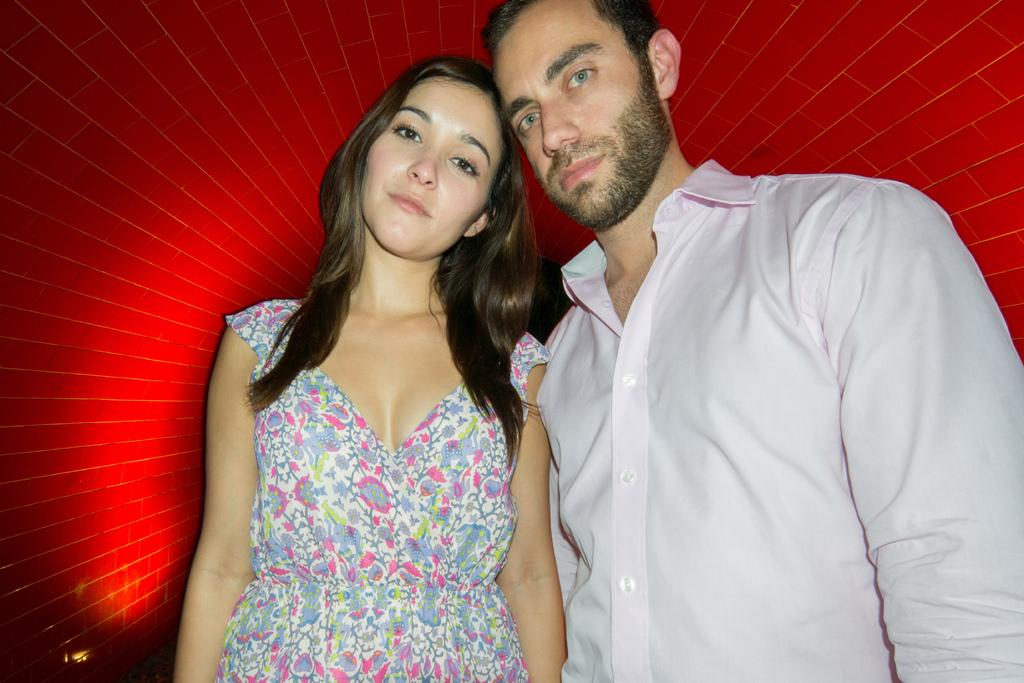Who are the people in the image? There is a man and a woman in the image. What are the man and woman doing in the image? The man and woman are standing. What type of rabbit can be seen hopping in the image? There is no rabbit present in the image. How do the man and woman show respect to each other in the image? The image does not provide information about how the man and woman show respect to each other. 